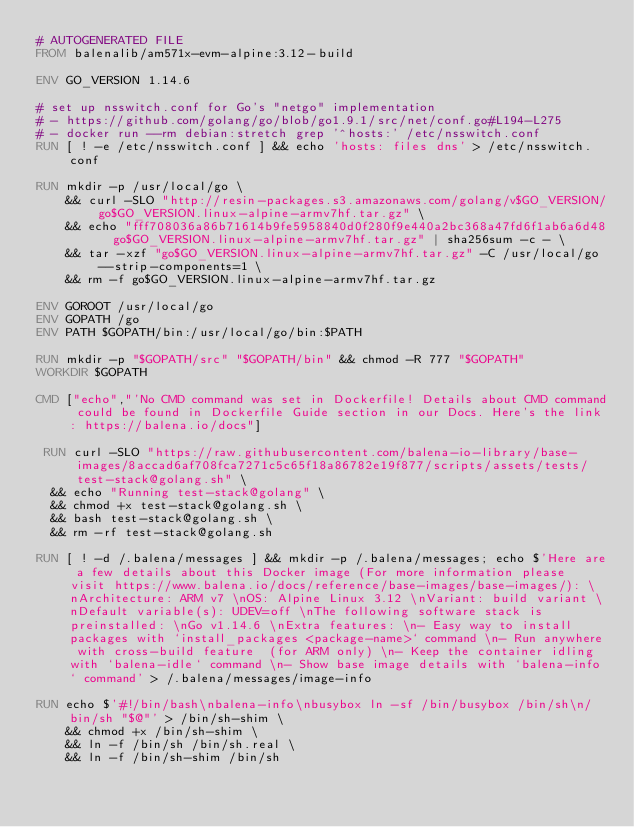Convert code to text. <code><loc_0><loc_0><loc_500><loc_500><_Dockerfile_># AUTOGENERATED FILE
FROM balenalib/am571x-evm-alpine:3.12-build

ENV GO_VERSION 1.14.6

# set up nsswitch.conf for Go's "netgo" implementation
# - https://github.com/golang/go/blob/go1.9.1/src/net/conf.go#L194-L275
# - docker run --rm debian:stretch grep '^hosts:' /etc/nsswitch.conf
RUN [ ! -e /etc/nsswitch.conf ] && echo 'hosts: files dns' > /etc/nsswitch.conf

RUN mkdir -p /usr/local/go \
	&& curl -SLO "http://resin-packages.s3.amazonaws.com/golang/v$GO_VERSION/go$GO_VERSION.linux-alpine-armv7hf.tar.gz" \
	&& echo "fff708036a86b71614b9fe5958840d0f280f9e440a2bc368a47fd6f1ab6a6d48  go$GO_VERSION.linux-alpine-armv7hf.tar.gz" | sha256sum -c - \
	&& tar -xzf "go$GO_VERSION.linux-alpine-armv7hf.tar.gz" -C /usr/local/go --strip-components=1 \
	&& rm -f go$GO_VERSION.linux-alpine-armv7hf.tar.gz

ENV GOROOT /usr/local/go
ENV GOPATH /go
ENV PATH $GOPATH/bin:/usr/local/go/bin:$PATH

RUN mkdir -p "$GOPATH/src" "$GOPATH/bin" && chmod -R 777 "$GOPATH"
WORKDIR $GOPATH

CMD ["echo","'No CMD command was set in Dockerfile! Details about CMD command could be found in Dockerfile Guide section in our Docs. Here's the link: https://balena.io/docs"]

 RUN curl -SLO "https://raw.githubusercontent.com/balena-io-library/base-images/8accad6af708fca7271c5c65f18a86782e19f877/scripts/assets/tests/test-stack@golang.sh" \
  && echo "Running test-stack@golang" \
  && chmod +x test-stack@golang.sh \
  && bash test-stack@golang.sh \
  && rm -rf test-stack@golang.sh 

RUN [ ! -d /.balena/messages ] && mkdir -p /.balena/messages; echo $'Here are a few details about this Docker image (For more information please visit https://www.balena.io/docs/reference/base-images/base-images/): \nArchitecture: ARM v7 \nOS: Alpine Linux 3.12 \nVariant: build variant \nDefault variable(s): UDEV=off \nThe following software stack is preinstalled: \nGo v1.14.6 \nExtra features: \n- Easy way to install packages with `install_packages <package-name>` command \n- Run anywhere with cross-build feature  (for ARM only) \n- Keep the container idling with `balena-idle` command \n- Show base image details with `balena-info` command' > /.balena/messages/image-info

RUN echo $'#!/bin/bash\nbalena-info\nbusybox ln -sf /bin/busybox /bin/sh\n/bin/sh "$@"' > /bin/sh-shim \
	&& chmod +x /bin/sh-shim \
	&& ln -f /bin/sh /bin/sh.real \
	&& ln -f /bin/sh-shim /bin/sh</code> 